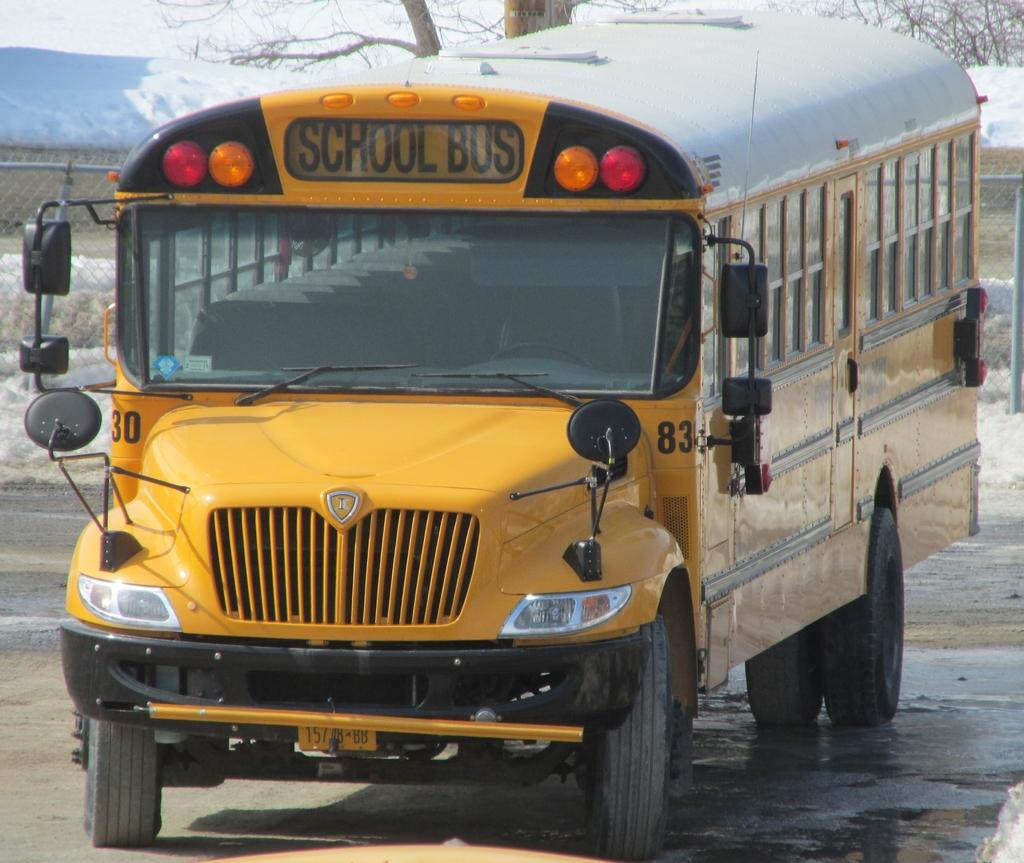What is the main subject of the image? The main subject of the image is a school bus. Where is the school bus located? The school bus is on the road. What can be seen in the background of the image? There is fencing and a tree in the background of the image. What type of floor can be seen inside the school bus in the image? There is no floor visible inside the school bus in the image, as the image only shows the exterior of the bus. 